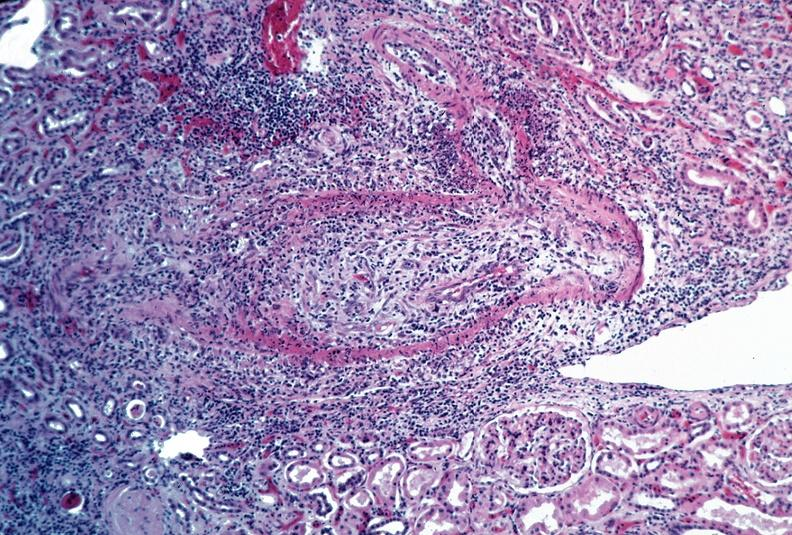s cardiovascular present?
Answer the question using a single word or phrase. Yes 